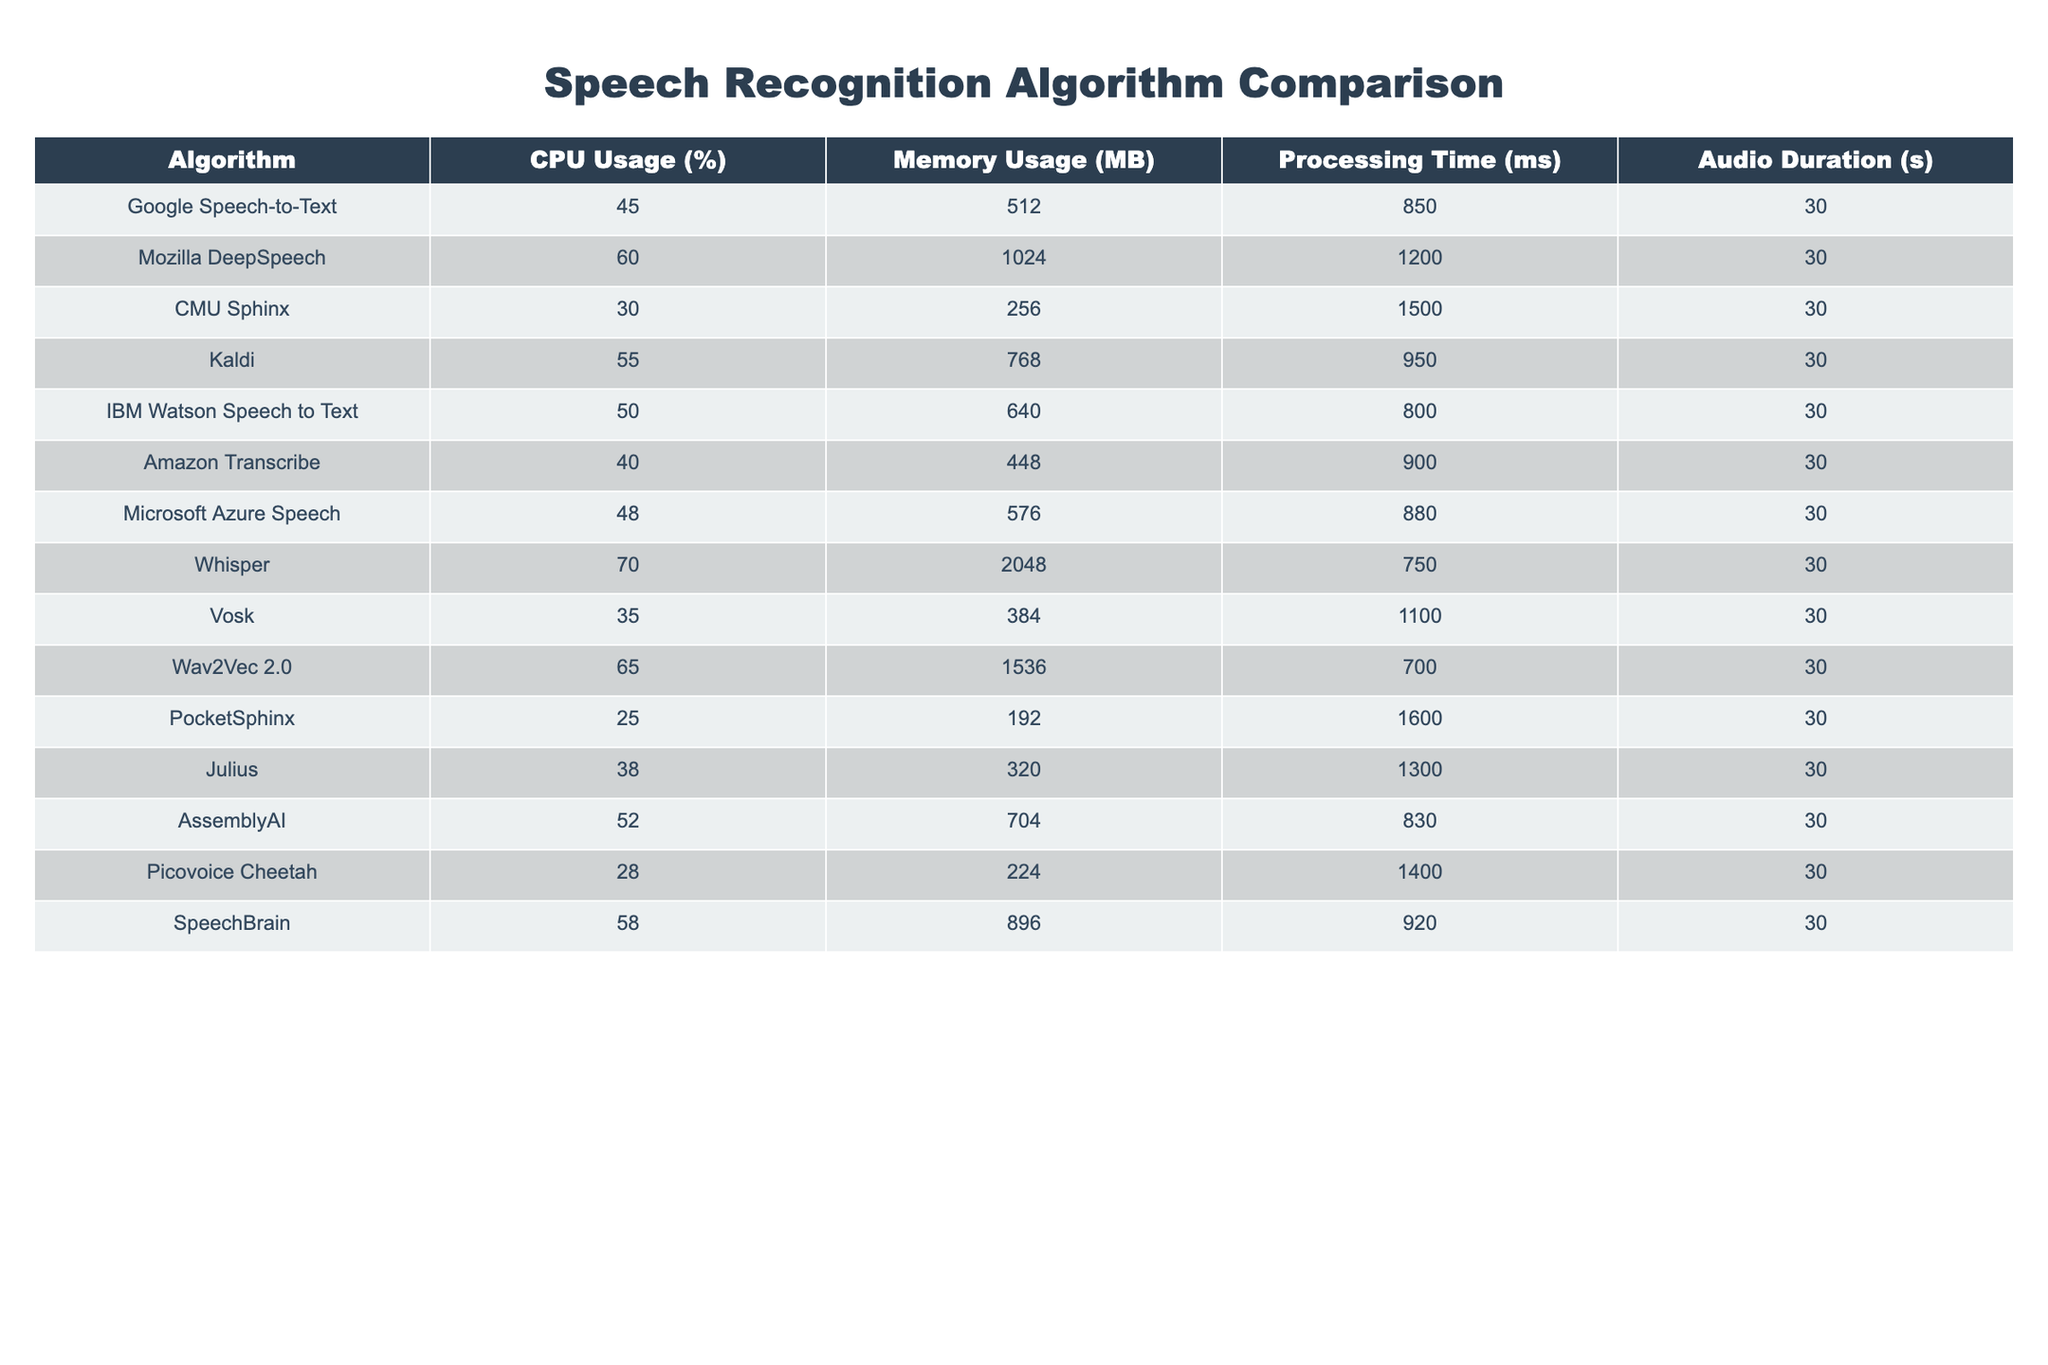What is the CPU usage of Whisper? The table shows that Whisper has a CPU usage of 70%.
Answer: 70% Which algorithm has the lowest memory usage? The table indicates that PocketSphinx has the lowest memory usage at 192 MB.
Answer: 192 MB What is the average processing time of all algorithms on the table? To calculate the average processing time, we sum the processing times (850 + 1200 + 1500 + 950 + 800 + 900 + 880 + 750 + 1100 + 700 + 1600 + 1300 + 830 + 1400 + 920) = 13880 ms. There are 14 algorithms, so the average is 13880 / 14 ≈ 990 ms.
Answer: 990 ms Is the CPU usage of Google Speech-to-Text higher than that of Amazon Transcribe? The CPU usage of Google Speech-to-Text is 45%, and Amazon Transcribe's CPU usage is 40%. Since 45% is greater than 40%, the statement is true.
Answer: Yes How much more memory does Vosk use than CMU Sphinx? Vosk uses 384 MB, and CMU Sphinx uses 256 MB. The difference is 384 - 256 = 128 MB.
Answer: 128 MB Which algorithms have a processing time longer than 1000 ms? Looking at the processing times, CMU Sphinx (1500 ms), Mozilla DeepSpeech (1200 ms), Vosk (1100 ms), and Julius (1300 ms) have times longer than 1000 ms.
Answer: CMU Sphinx, Mozilla DeepSpeech, Vosk, Julius What is the total CPU usage of all algorithms combined? To find the total CPU usage, we sum the individual CPU usages (45 + 60 + 30 + 55 + 50 + 40 + 48 + 70 + 35 + 65 + 25 + 38 + 52 + 58) =  856%.
Answer: 856% If an algorithm's memory usage is doubled, which one, if any, would exceed 2048 MB? The algorithms with the highest memory usage are Whisper (2048 MB) and Wav2Vec 2.0 (1536 MB). If Wav2Vec 2.0's memory usage is doubled, it would exceed 2048 MB (1536 * 2 = 3072 MB). Therefore, only Wav2Vec 2.0 would exceed 2048 MB.
Answer: Wav2Vec 2.0 What is the ratio of CPU usage to processing time for IBM Watson Speech to Text? IBM Watson Speech to Text has a CPU usage of 50% and a processing time of 800 ms. The ratio is 50 / 800 = 0.0625.
Answer: 0.0625 Which algorithm has the highest memory usage and what is its CPU usage? The highest memory usage algorithm is Whisper at 2048 MB, and its CPU usage is 70%.
Answer: Whisper, 70% 